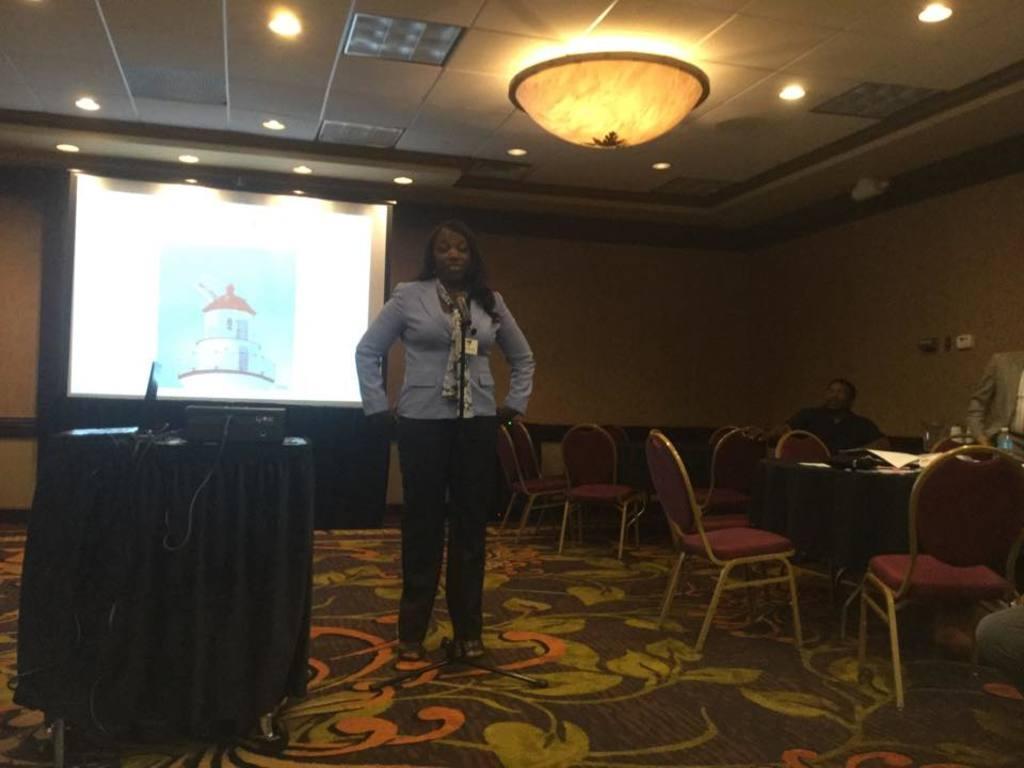Describe this image in one or two sentences. As we can see in the image there is a woman standing. Behind the women there is a wall, screen and there are drums on the left side, tables and chairs on the right side. 